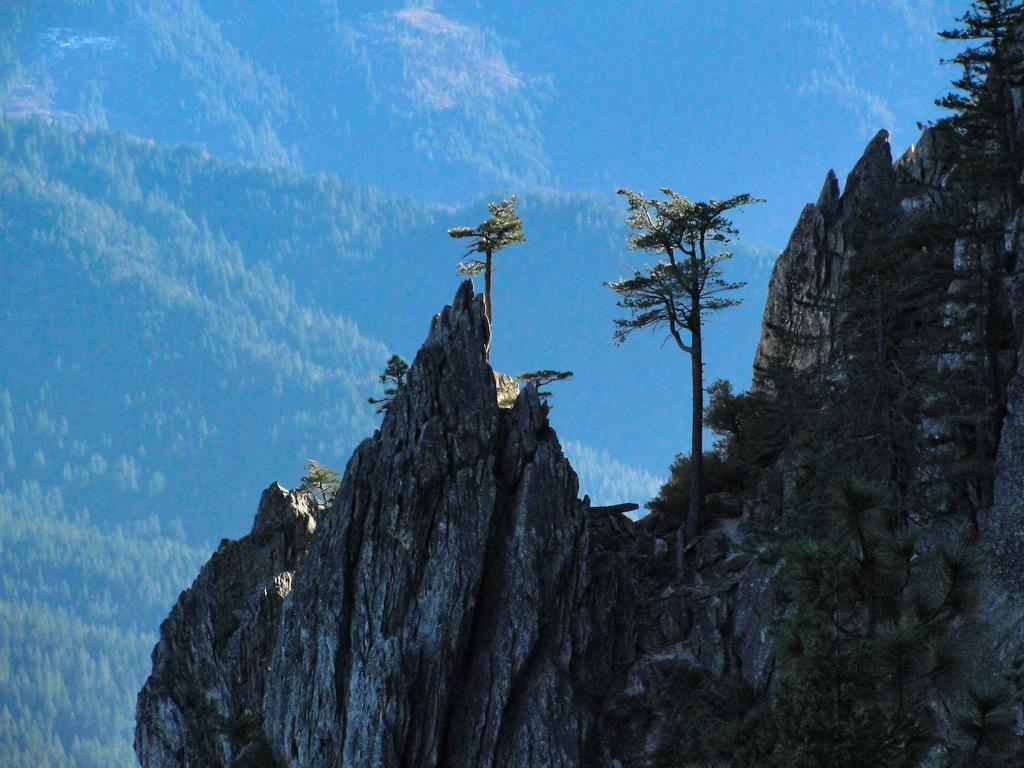What is the main feature in the image? There is a mountain in the image. What can be seen on the mountain? There are trees on the mountain. What is visible in the background of the image? The sky is visible in the background of the image. What type of vase can be seen on the mountain in the image? There is no vase present on the mountain in the image. How does the comb help the trees on the mountain in the image? There is no comb present in the image, and therefore it cannot help the trees on the mountain. 